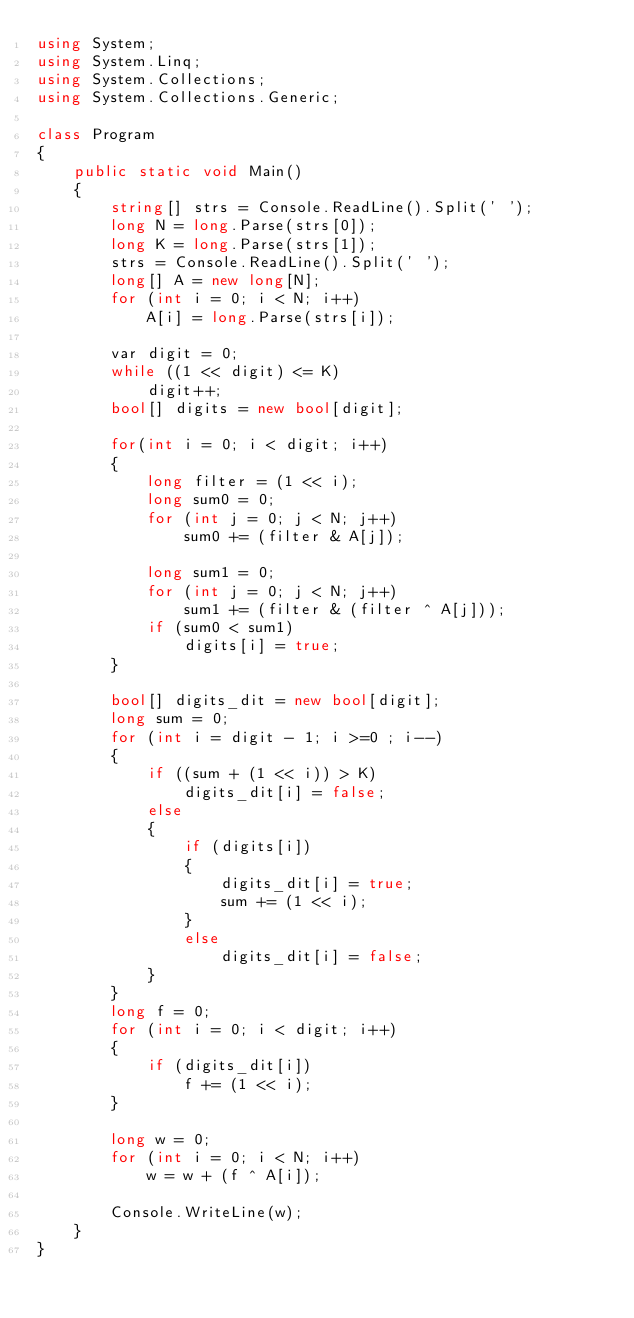<code> <loc_0><loc_0><loc_500><loc_500><_C#_>using System;
using System.Linq;
using System.Collections;
using System.Collections.Generic;

class Program
{
    public static void Main()
    {
        string[] strs = Console.ReadLine().Split(' ');
        long N = long.Parse(strs[0]);
        long K = long.Parse(strs[1]);
        strs = Console.ReadLine().Split(' ');
        long[] A = new long[N];
        for (int i = 0; i < N; i++)
            A[i] = long.Parse(strs[i]);
        
        var digit = 0;
        while ((1 << digit) <= K)
            digit++;
        bool[] digits = new bool[digit];

        for(int i = 0; i < digit; i++)
        {
            long filter = (1 << i);
            long sum0 = 0;
            for (int j = 0; j < N; j++)
                sum0 += (filter & A[j]);

            long sum1 = 0;
            for (int j = 0; j < N; j++)
                sum1 += (filter & (filter ^ A[j]));
            if (sum0 < sum1)
                digits[i] = true;
        }

        bool[] digits_dit = new bool[digit];
        long sum = 0;
        for (int i = digit - 1; i >=0 ; i--)
        {
            if ((sum + (1 << i)) > K)
                digits_dit[i] = false;
            else
            {
                if (digits[i])
                {
                    digits_dit[i] = true;
                    sum += (1 << i);
                }
                else
                    digits_dit[i] = false;
            }
        }
        long f = 0;
        for (int i = 0; i < digit; i++)
        {
            if (digits_dit[i])
                f += (1 << i);
        }

        long w = 0;
        for (int i = 0; i < N; i++)
            w = w + (f ^ A[i]);

        Console.WriteLine(w);
    }
}</code> 